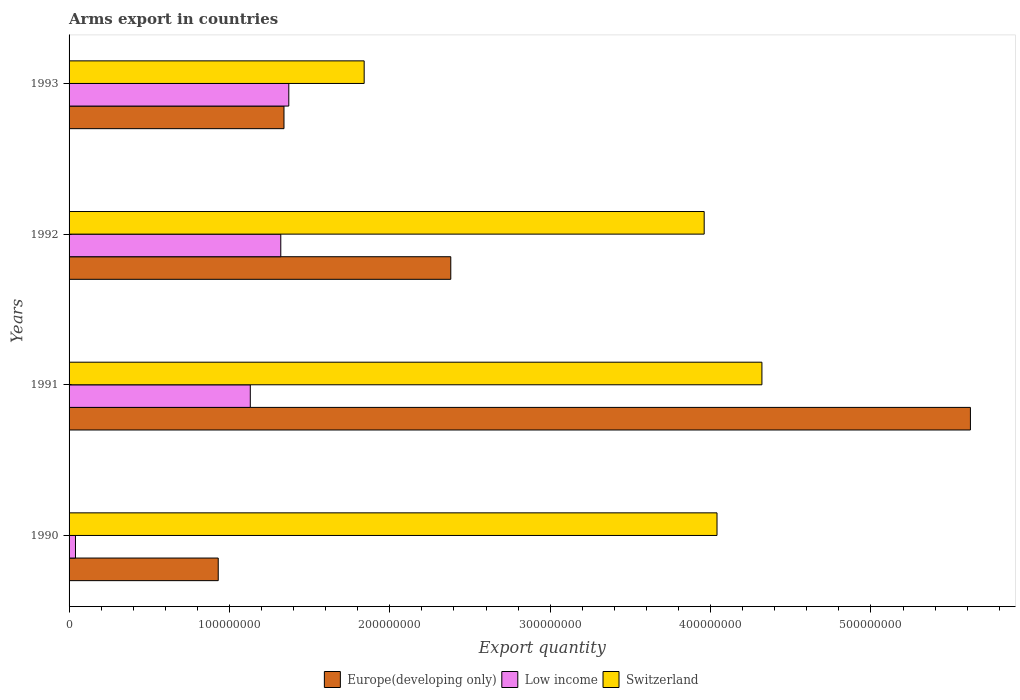How many different coloured bars are there?
Provide a succinct answer. 3. How many groups of bars are there?
Provide a succinct answer. 4. Are the number of bars on each tick of the Y-axis equal?
Make the answer very short. Yes. How many bars are there on the 1st tick from the top?
Offer a very short reply. 3. What is the label of the 4th group of bars from the top?
Ensure brevity in your answer.  1990. In how many cases, is the number of bars for a given year not equal to the number of legend labels?
Provide a succinct answer. 0. What is the total arms export in Low income in 1992?
Offer a very short reply. 1.32e+08. Across all years, what is the maximum total arms export in Switzerland?
Provide a succinct answer. 4.32e+08. Across all years, what is the minimum total arms export in Europe(developing only)?
Ensure brevity in your answer.  9.30e+07. What is the total total arms export in Switzerland in the graph?
Your response must be concise. 1.42e+09. What is the difference between the total arms export in Europe(developing only) in 1991 and that in 1993?
Offer a very short reply. 4.28e+08. What is the difference between the total arms export in Europe(developing only) in 1990 and the total arms export in Low income in 1992?
Give a very brief answer. -3.90e+07. What is the average total arms export in Low income per year?
Keep it short and to the point. 9.65e+07. In the year 1992, what is the difference between the total arms export in Switzerland and total arms export in Low income?
Provide a succinct answer. 2.64e+08. What is the ratio of the total arms export in Switzerland in 1991 to that in 1992?
Keep it short and to the point. 1.09. What is the difference between the highest and the second highest total arms export in Switzerland?
Offer a terse response. 2.80e+07. What is the difference between the highest and the lowest total arms export in Switzerland?
Keep it short and to the point. 2.48e+08. In how many years, is the total arms export in Europe(developing only) greater than the average total arms export in Europe(developing only) taken over all years?
Ensure brevity in your answer.  1. Is the sum of the total arms export in Switzerland in 1990 and 1992 greater than the maximum total arms export in Europe(developing only) across all years?
Your response must be concise. Yes. What does the 1st bar from the top in 1993 represents?
Ensure brevity in your answer.  Switzerland. What does the 3rd bar from the bottom in 1990 represents?
Provide a succinct answer. Switzerland. How many bars are there?
Keep it short and to the point. 12. Are all the bars in the graph horizontal?
Offer a terse response. Yes. What is the difference between two consecutive major ticks on the X-axis?
Offer a terse response. 1.00e+08. Are the values on the major ticks of X-axis written in scientific E-notation?
Offer a very short reply. No. Does the graph contain grids?
Keep it short and to the point. No. How many legend labels are there?
Your answer should be very brief. 3. How are the legend labels stacked?
Provide a succinct answer. Horizontal. What is the title of the graph?
Give a very brief answer. Arms export in countries. What is the label or title of the X-axis?
Your answer should be very brief. Export quantity. What is the label or title of the Y-axis?
Your answer should be compact. Years. What is the Export quantity of Europe(developing only) in 1990?
Your answer should be very brief. 9.30e+07. What is the Export quantity of Switzerland in 1990?
Offer a terse response. 4.04e+08. What is the Export quantity in Europe(developing only) in 1991?
Your answer should be compact. 5.62e+08. What is the Export quantity in Low income in 1991?
Offer a terse response. 1.13e+08. What is the Export quantity in Switzerland in 1991?
Keep it short and to the point. 4.32e+08. What is the Export quantity in Europe(developing only) in 1992?
Your response must be concise. 2.38e+08. What is the Export quantity of Low income in 1992?
Offer a terse response. 1.32e+08. What is the Export quantity in Switzerland in 1992?
Ensure brevity in your answer.  3.96e+08. What is the Export quantity of Europe(developing only) in 1993?
Your answer should be very brief. 1.34e+08. What is the Export quantity in Low income in 1993?
Ensure brevity in your answer.  1.37e+08. What is the Export quantity in Switzerland in 1993?
Give a very brief answer. 1.84e+08. Across all years, what is the maximum Export quantity of Europe(developing only)?
Keep it short and to the point. 5.62e+08. Across all years, what is the maximum Export quantity in Low income?
Provide a succinct answer. 1.37e+08. Across all years, what is the maximum Export quantity of Switzerland?
Your response must be concise. 4.32e+08. Across all years, what is the minimum Export quantity in Europe(developing only)?
Provide a succinct answer. 9.30e+07. Across all years, what is the minimum Export quantity of Switzerland?
Your answer should be very brief. 1.84e+08. What is the total Export quantity in Europe(developing only) in the graph?
Your answer should be compact. 1.03e+09. What is the total Export quantity of Low income in the graph?
Offer a terse response. 3.86e+08. What is the total Export quantity in Switzerland in the graph?
Your answer should be very brief. 1.42e+09. What is the difference between the Export quantity of Europe(developing only) in 1990 and that in 1991?
Offer a terse response. -4.69e+08. What is the difference between the Export quantity in Low income in 1990 and that in 1991?
Keep it short and to the point. -1.09e+08. What is the difference between the Export quantity of Switzerland in 1990 and that in 1991?
Offer a terse response. -2.80e+07. What is the difference between the Export quantity of Europe(developing only) in 1990 and that in 1992?
Give a very brief answer. -1.45e+08. What is the difference between the Export quantity of Low income in 1990 and that in 1992?
Provide a short and direct response. -1.28e+08. What is the difference between the Export quantity in Switzerland in 1990 and that in 1992?
Offer a terse response. 8.00e+06. What is the difference between the Export quantity in Europe(developing only) in 1990 and that in 1993?
Your answer should be compact. -4.10e+07. What is the difference between the Export quantity of Low income in 1990 and that in 1993?
Offer a very short reply. -1.33e+08. What is the difference between the Export quantity of Switzerland in 1990 and that in 1993?
Ensure brevity in your answer.  2.20e+08. What is the difference between the Export quantity of Europe(developing only) in 1991 and that in 1992?
Offer a terse response. 3.24e+08. What is the difference between the Export quantity in Low income in 1991 and that in 1992?
Keep it short and to the point. -1.90e+07. What is the difference between the Export quantity in Switzerland in 1991 and that in 1992?
Your answer should be compact. 3.60e+07. What is the difference between the Export quantity of Europe(developing only) in 1991 and that in 1993?
Make the answer very short. 4.28e+08. What is the difference between the Export quantity in Low income in 1991 and that in 1993?
Your answer should be very brief. -2.40e+07. What is the difference between the Export quantity of Switzerland in 1991 and that in 1993?
Your answer should be compact. 2.48e+08. What is the difference between the Export quantity in Europe(developing only) in 1992 and that in 1993?
Provide a succinct answer. 1.04e+08. What is the difference between the Export quantity of Low income in 1992 and that in 1993?
Your answer should be very brief. -5.00e+06. What is the difference between the Export quantity in Switzerland in 1992 and that in 1993?
Ensure brevity in your answer.  2.12e+08. What is the difference between the Export quantity of Europe(developing only) in 1990 and the Export quantity of Low income in 1991?
Offer a very short reply. -2.00e+07. What is the difference between the Export quantity in Europe(developing only) in 1990 and the Export quantity in Switzerland in 1991?
Your answer should be very brief. -3.39e+08. What is the difference between the Export quantity of Low income in 1990 and the Export quantity of Switzerland in 1991?
Keep it short and to the point. -4.28e+08. What is the difference between the Export quantity of Europe(developing only) in 1990 and the Export quantity of Low income in 1992?
Offer a very short reply. -3.90e+07. What is the difference between the Export quantity of Europe(developing only) in 1990 and the Export quantity of Switzerland in 1992?
Make the answer very short. -3.03e+08. What is the difference between the Export quantity of Low income in 1990 and the Export quantity of Switzerland in 1992?
Make the answer very short. -3.92e+08. What is the difference between the Export quantity in Europe(developing only) in 1990 and the Export quantity in Low income in 1993?
Give a very brief answer. -4.40e+07. What is the difference between the Export quantity of Europe(developing only) in 1990 and the Export quantity of Switzerland in 1993?
Ensure brevity in your answer.  -9.10e+07. What is the difference between the Export quantity in Low income in 1990 and the Export quantity in Switzerland in 1993?
Provide a succinct answer. -1.80e+08. What is the difference between the Export quantity of Europe(developing only) in 1991 and the Export quantity of Low income in 1992?
Provide a short and direct response. 4.30e+08. What is the difference between the Export quantity in Europe(developing only) in 1991 and the Export quantity in Switzerland in 1992?
Make the answer very short. 1.66e+08. What is the difference between the Export quantity of Low income in 1991 and the Export quantity of Switzerland in 1992?
Your answer should be very brief. -2.83e+08. What is the difference between the Export quantity of Europe(developing only) in 1991 and the Export quantity of Low income in 1993?
Your response must be concise. 4.25e+08. What is the difference between the Export quantity in Europe(developing only) in 1991 and the Export quantity in Switzerland in 1993?
Your response must be concise. 3.78e+08. What is the difference between the Export quantity in Low income in 1991 and the Export quantity in Switzerland in 1993?
Offer a terse response. -7.10e+07. What is the difference between the Export quantity of Europe(developing only) in 1992 and the Export quantity of Low income in 1993?
Give a very brief answer. 1.01e+08. What is the difference between the Export quantity of Europe(developing only) in 1992 and the Export quantity of Switzerland in 1993?
Give a very brief answer. 5.40e+07. What is the difference between the Export quantity of Low income in 1992 and the Export quantity of Switzerland in 1993?
Make the answer very short. -5.20e+07. What is the average Export quantity of Europe(developing only) per year?
Provide a succinct answer. 2.57e+08. What is the average Export quantity in Low income per year?
Give a very brief answer. 9.65e+07. What is the average Export quantity of Switzerland per year?
Provide a succinct answer. 3.54e+08. In the year 1990, what is the difference between the Export quantity of Europe(developing only) and Export quantity of Low income?
Provide a succinct answer. 8.90e+07. In the year 1990, what is the difference between the Export quantity in Europe(developing only) and Export quantity in Switzerland?
Your response must be concise. -3.11e+08. In the year 1990, what is the difference between the Export quantity of Low income and Export quantity of Switzerland?
Make the answer very short. -4.00e+08. In the year 1991, what is the difference between the Export quantity of Europe(developing only) and Export quantity of Low income?
Provide a succinct answer. 4.49e+08. In the year 1991, what is the difference between the Export quantity in Europe(developing only) and Export quantity in Switzerland?
Ensure brevity in your answer.  1.30e+08. In the year 1991, what is the difference between the Export quantity in Low income and Export quantity in Switzerland?
Make the answer very short. -3.19e+08. In the year 1992, what is the difference between the Export quantity in Europe(developing only) and Export quantity in Low income?
Ensure brevity in your answer.  1.06e+08. In the year 1992, what is the difference between the Export quantity of Europe(developing only) and Export quantity of Switzerland?
Your response must be concise. -1.58e+08. In the year 1992, what is the difference between the Export quantity in Low income and Export quantity in Switzerland?
Your answer should be compact. -2.64e+08. In the year 1993, what is the difference between the Export quantity in Europe(developing only) and Export quantity in Switzerland?
Your response must be concise. -5.00e+07. In the year 1993, what is the difference between the Export quantity in Low income and Export quantity in Switzerland?
Make the answer very short. -4.70e+07. What is the ratio of the Export quantity in Europe(developing only) in 1990 to that in 1991?
Offer a terse response. 0.17. What is the ratio of the Export quantity in Low income in 1990 to that in 1991?
Offer a very short reply. 0.04. What is the ratio of the Export quantity of Switzerland in 1990 to that in 1991?
Provide a short and direct response. 0.94. What is the ratio of the Export quantity of Europe(developing only) in 1990 to that in 1992?
Offer a very short reply. 0.39. What is the ratio of the Export quantity of Low income in 1990 to that in 1992?
Provide a succinct answer. 0.03. What is the ratio of the Export quantity in Switzerland in 1990 to that in 1992?
Provide a short and direct response. 1.02. What is the ratio of the Export quantity of Europe(developing only) in 1990 to that in 1993?
Offer a very short reply. 0.69. What is the ratio of the Export quantity in Low income in 1990 to that in 1993?
Your response must be concise. 0.03. What is the ratio of the Export quantity of Switzerland in 1990 to that in 1993?
Offer a terse response. 2.2. What is the ratio of the Export quantity of Europe(developing only) in 1991 to that in 1992?
Offer a terse response. 2.36. What is the ratio of the Export quantity in Low income in 1991 to that in 1992?
Provide a succinct answer. 0.86. What is the ratio of the Export quantity in Switzerland in 1991 to that in 1992?
Give a very brief answer. 1.09. What is the ratio of the Export quantity of Europe(developing only) in 1991 to that in 1993?
Provide a short and direct response. 4.19. What is the ratio of the Export quantity in Low income in 1991 to that in 1993?
Your answer should be compact. 0.82. What is the ratio of the Export quantity in Switzerland in 1991 to that in 1993?
Provide a succinct answer. 2.35. What is the ratio of the Export quantity of Europe(developing only) in 1992 to that in 1993?
Keep it short and to the point. 1.78. What is the ratio of the Export quantity in Low income in 1992 to that in 1993?
Offer a very short reply. 0.96. What is the ratio of the Export quantity in Switzerland in 1992 to that in 1993?
Provide a short and direct response. 2.15. What is the difference between the highest and the second highest Export quantity of Europe(developing only)?
Provide a succinct answer. 3.24e+08. What is the difference between the highest and the second highest Export quantity in Low income?
Your answer should be compact. 5.00e+06. What is the difference between the highest and the second highest Export quantity in Switzerland?
Provide a succinct answer. 2.80e+07. What is the difference between the highest and the lowest Export quantity in Europe(developing only)?
Provide a short and direct response. 4.69e+08. What is the difference between the highest and the lowest Export quantity in Low income?
Make the answer very short. 1.33e+08. What is the difference between the highest and the lowest Export quantity in Switzerland?
Give a very brief answer. 2.48e+08. 